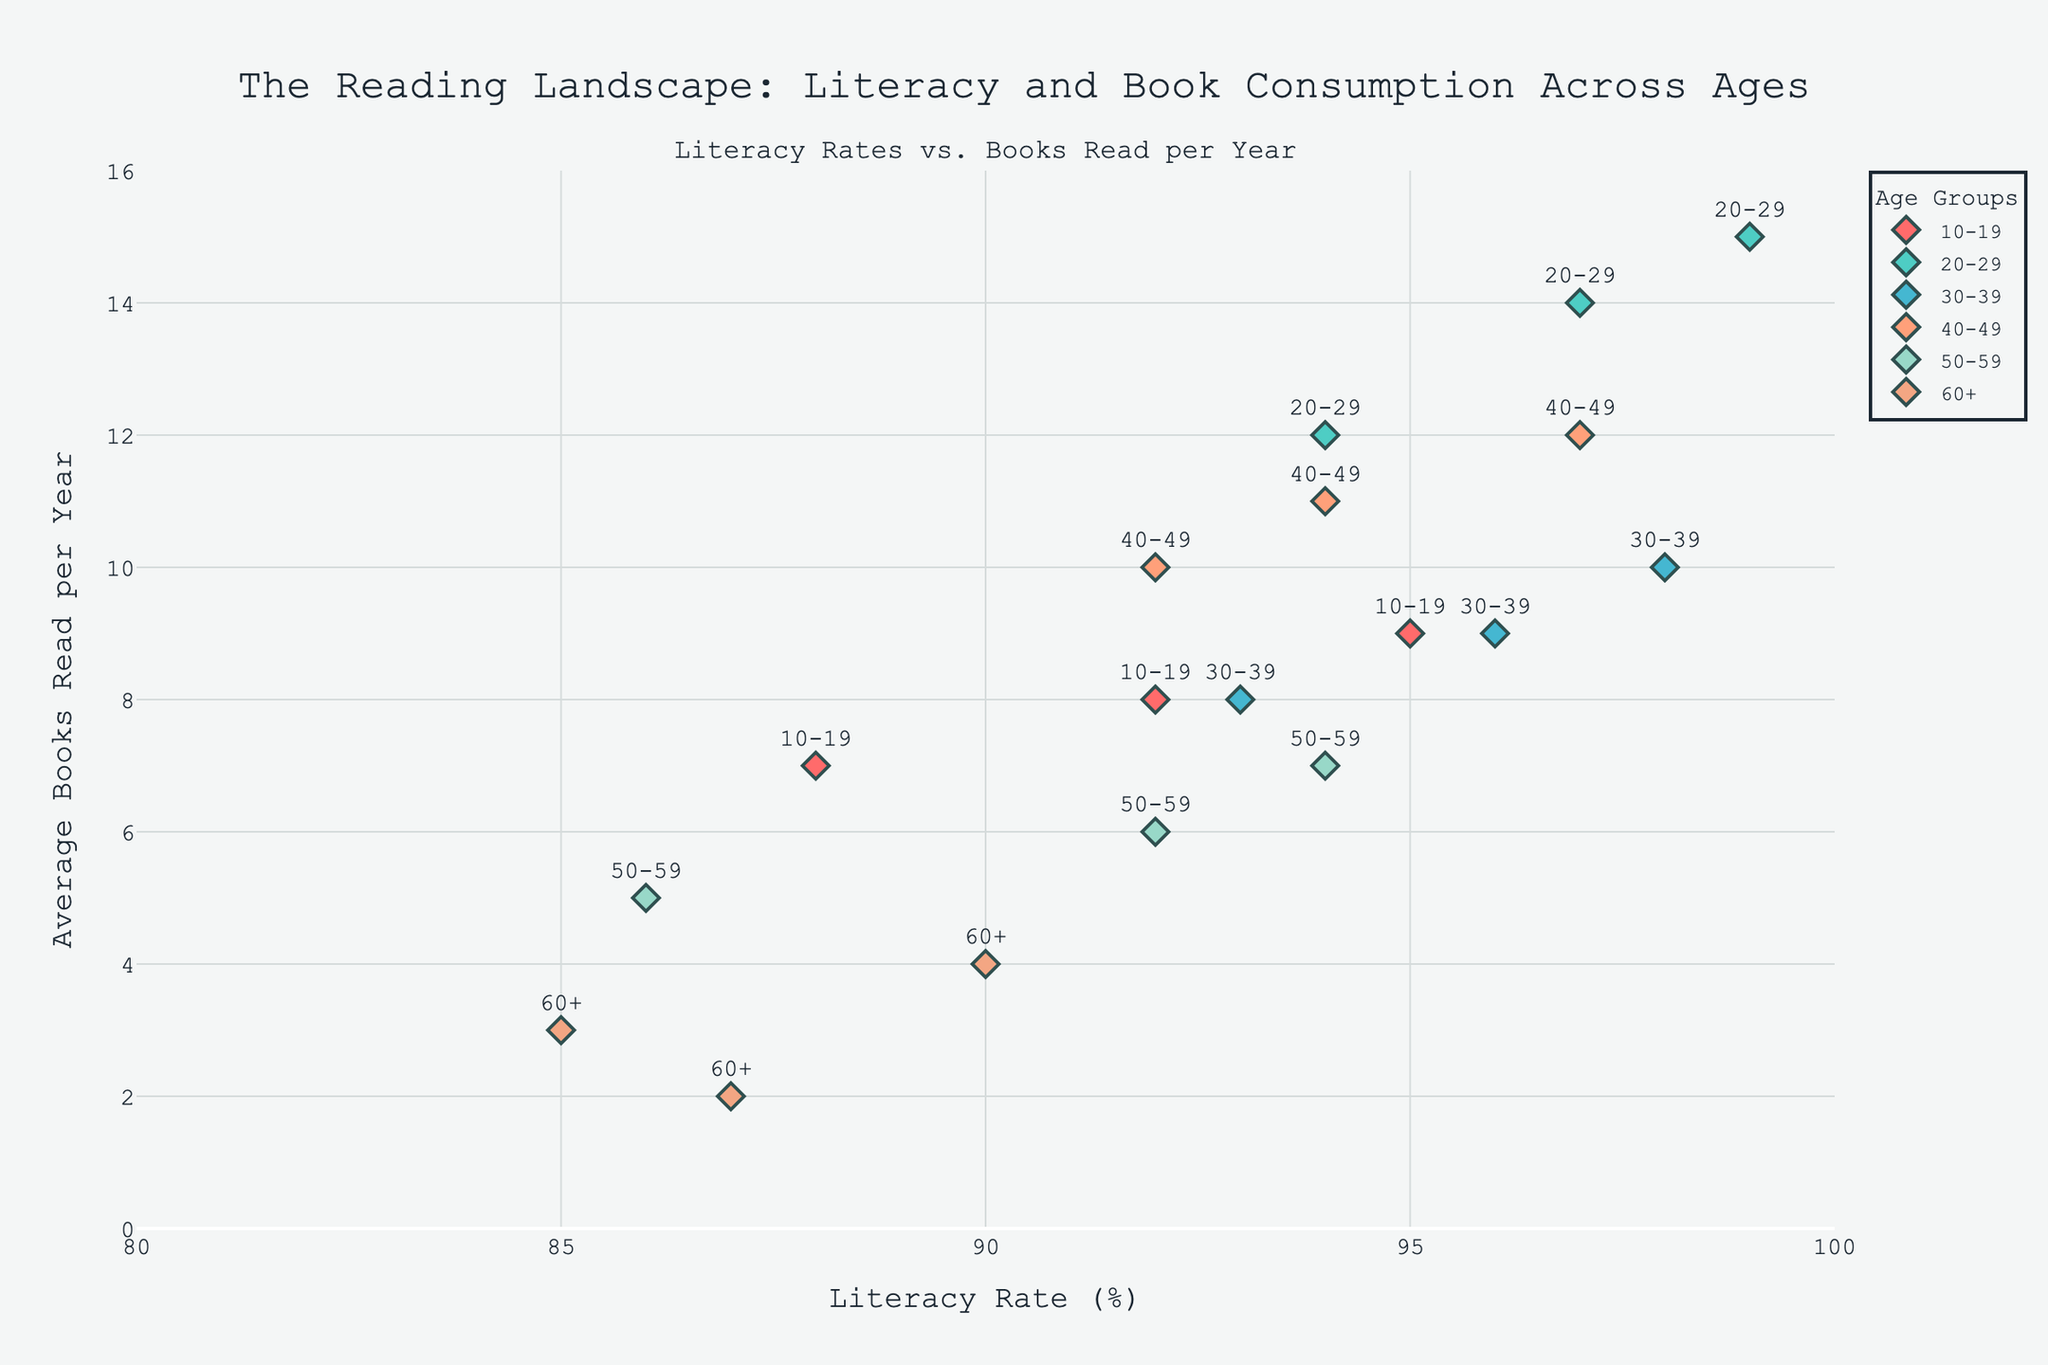What is the title of the plot? The title of the plot is displayed at the top and reads "The Reading Landscape: Literacy and Book Consumption Across Ages"
Answer: The Reading Landscape: Literacy and Book Consumption Across Ages Which age group has the highest average number of books read per year? From the plot, the 20-29 age group shows the highest average number of books read per year, as visible through their data points towards the higher end of the y-axis.
Answer: 20-29 What is the color used to represent the 30-39 age group? By observing the legend and the plot, the 30-39 age group is represented by a light blue color (#98D8C8).
Answer: Light blue What is the range of Literacy Rates displayed on the x-axis? The x-axis displays literacy rates ranging from 80% to 100%, as indicated by the axis ticks and labels.
Answer: 80% to 100% How many total data points are there for the 60+ age group? By counting the markers in the plot for the 60+ age group, there are three data points visible in the figure.
Answer: 3 What is the average literacy rate for the 40-49 age group? To find the average, sum the literacy rates of 40-49 age group data points (97 + 92 + 94) and divide by 3. (97 + 92 + 94) / 3 = 283 / 3 = 94.33
Answer: 94.33 Which age group shows the largest variation in the average number of books read per year? By examining the spread of data points on the y-axis, the 50-59 age group shows a large variation, ranging from 2 to 7 books read per year.
Answer: 50-59 What is the literacy rate for the age group that reads the fewest books on average? The 60+ age group reads the fewest books on average (2-4). Their literacy rates are 90%, 85%, and 87%.
Answer: 85%, 87%, 90% Compare the literacy rate of the 20-29 age group with the 50-59 age group. The 20-29 age group shows higher literacy rates (94%, 97%, 99%) compared to the 50-59 age group (86%, 92%, 94%).
Answer: 20-29 higher What is the difference in average books read per year between the age groups 10-19 and 30-39? Calculate the average books read for 10-19 (8+7+9)/3 = 8 and for 30-39 (10+8+9)/3 = 9. Difference = 9 - 8 = 1
Answer: 1 